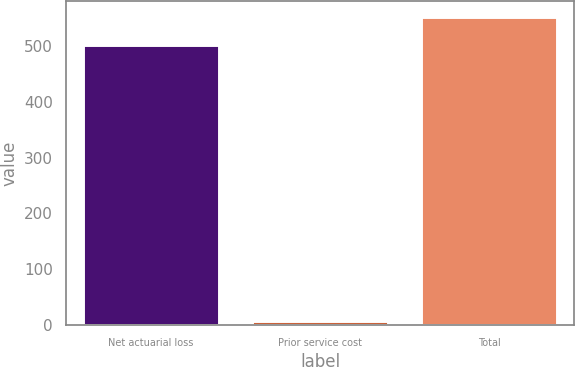<chart> <loc_0><loc_0><loc_500><loc_500><bar_chart><fcel>Net actuarial loss<fcel>Prior service cost<fcel>Total<nl><fcel>502.5<fcel>6<fcel>552.79<nl></chart> 